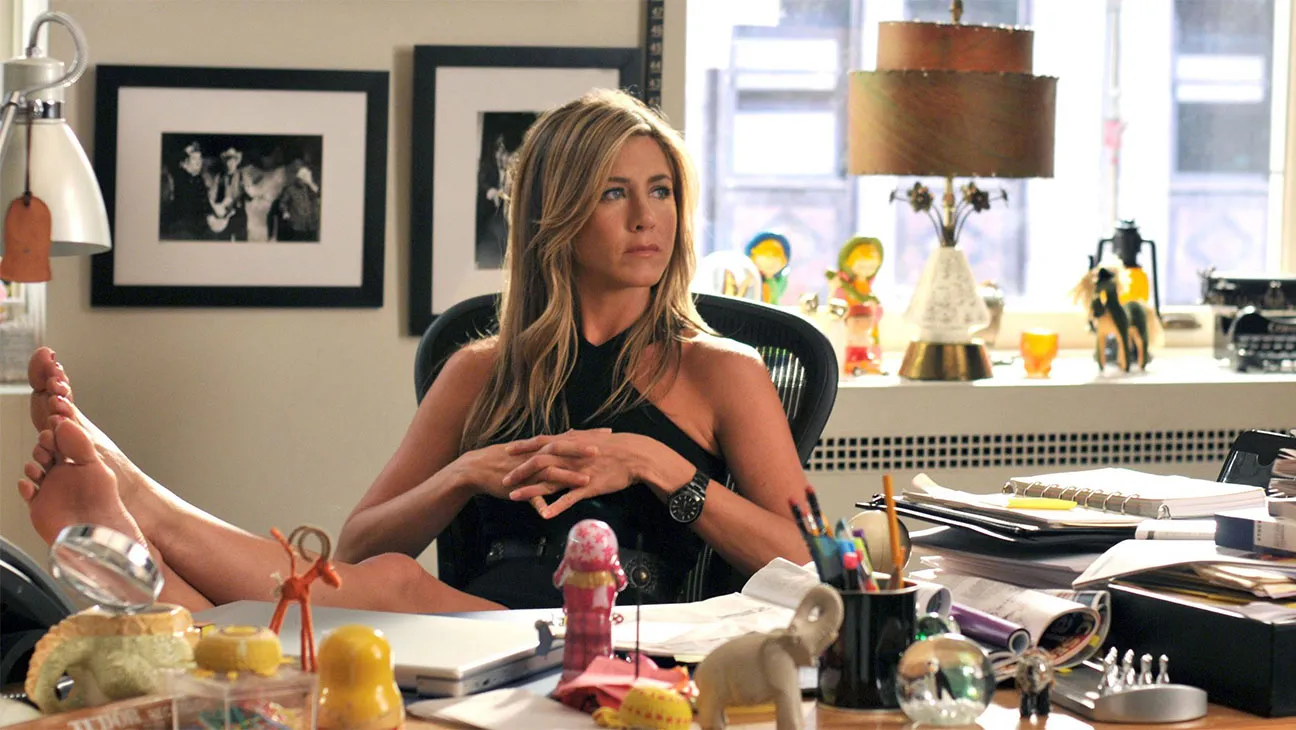Describe the following image. The image portrays a woman seated at a cluttered desk in an office setting. She is dressed in a chic black sleeveless dress and sits with her feet resting on the table, conveying a relaxed yet authoritative aura. Her arms are crossed, and she gazes to the side with a contemplative expression. The desk is filled with a variety of objects, including a lamp, a pile of papers, an open notebook, some colorful desk toys, and a mobile phone, illustrating a personal and professional space. The background shows a window that provides a glimpse into a room adorned with framed artworks. 